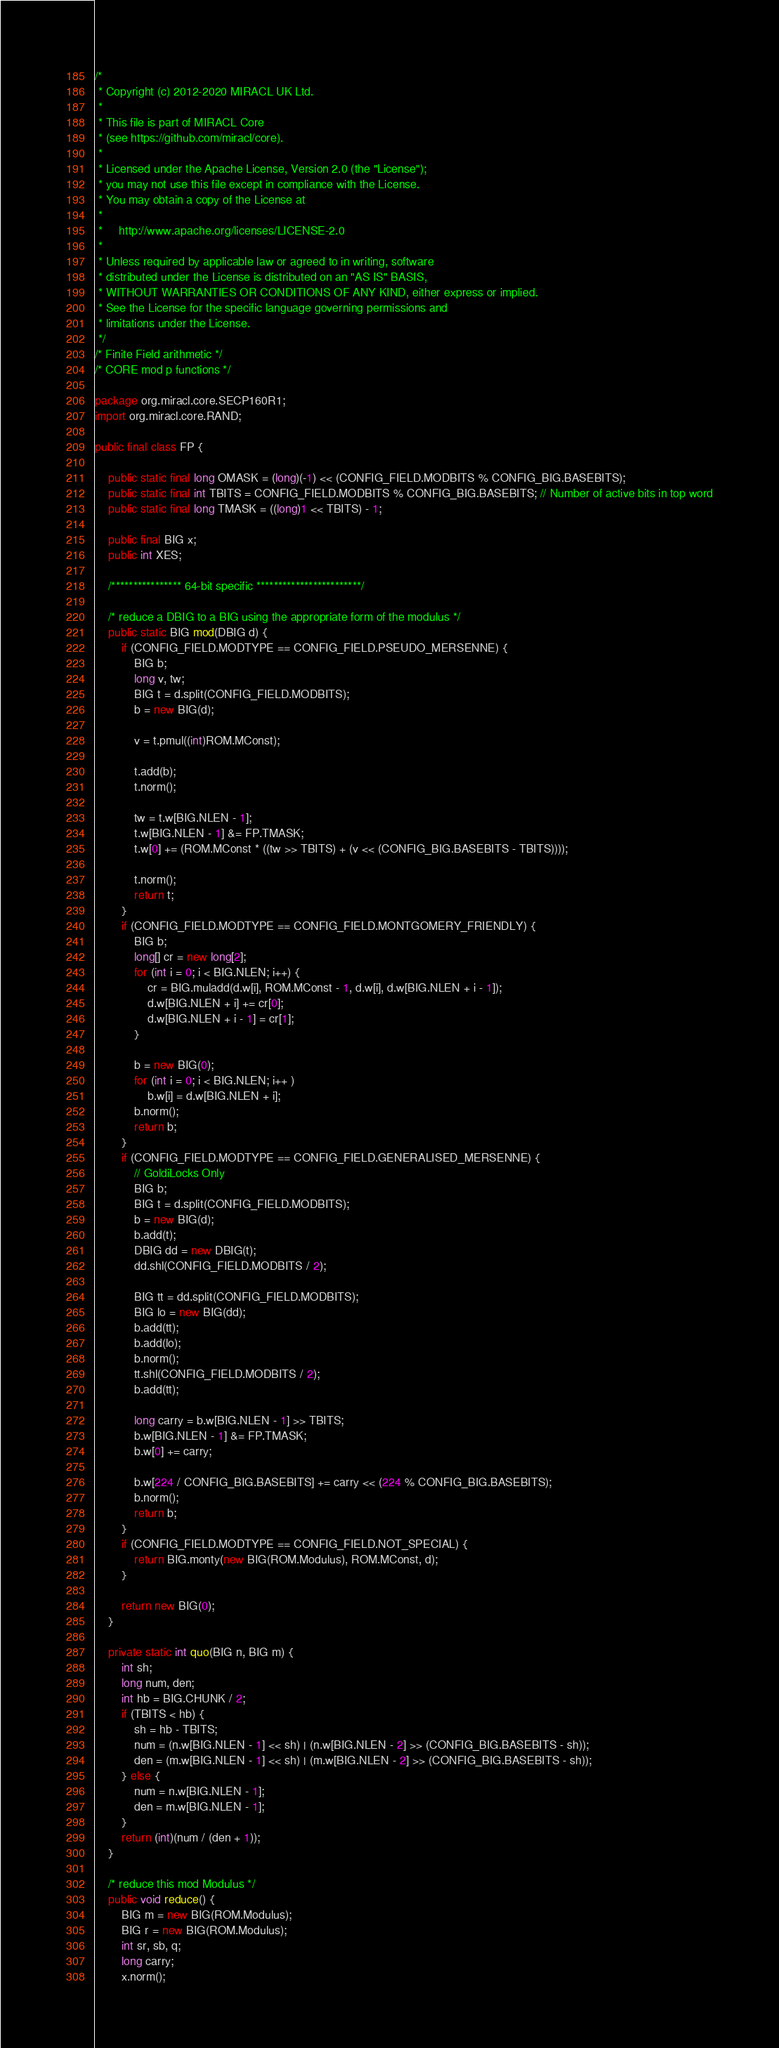<code> <loc_0><loc_0><loc_500><loc_500><_Java_>/*
 * Copyright (c) 2012-2020 MIRACL UK Ltd.
 *
 * This file is part of MIRACL Core
 * (see https://github.com/miracl/core).
 *
 * Licensed under the Apache License, Version 2.0 (the "License");
 * you may not use this file except in compliance with the License.
 * You may obtain a copy of the License at
 *
 *     http://www.apache.org/licenses/LICENSE-2.0
 *
 * Unless required by applicable law or agreed to in writing, software
 * distributed under the License is distributed on an "AS IS" BASIS,
 * WITHOUT WARRANTIES OR CONDITIONS OF ANY KIND, either express or implied.
 * See the License for the specific language governing permissions and
 * limitations under the License.
 */
/* Finite Field arithmetic */
/* CORE mod p functions */

package org.miracl.core.SECP160R1;
import org.miracl.core.RAND;

public final class FP {

    public static final long OMASK = (long)(-1) << (CONFIG_FIELD.MODBITS % CONFIG_BIG.BASEBITS);
    public static final int TBITS = CONFIG_FIELD.MODBITS % CONFIG_BIG.BASEBITS; // Number of active bits in top word
    public static final long TMASK = ((long)1 << TBITS) - 1;

    public final BIG x;
    public int XES;

    /**************** 64-bit specific ************************/

    /* reduce a DBIG to a BIG using the appropriate form of the modulus */
    public static BIG mod(DBIG d) {
        if (CONFIG_FIELD.MODTYPE == CONFIG_FIELD.PSEUDO_MERSENNE) {
            BIG b;
            long v, tw;
            BIG t = d.split(CONFIG_FIELD.MODBITS);
            b = new BIG(d);

            v = t.pmul((int)ROM.MConst);

            t.add(b);
            t.norm();

            tw = t.w[BIG.NLEN - 1];
            t.w[BIG.NLEN - 1] &= FP.TMASK;
            t.w[0] += (ROM.MConst * ((tw >> TBITS) + (v << (CONFIG_BIG.BASEBITS - TBITS))));

            t.norm();
            return t;
        }
        if (CONFIG_FIELD.MODTYPE == CONFIG_FIELD.MONTGOMERY_FRIENDLY) {
            BIG b;
            long[] cr = new long[2];
            for (int i = 0; i < BIG.NLEN; i++) {
                cr = BIG.muladd(d.w[i], ROM.MConst - 1, d.w[i], d.w[BIG.NLEN + i - 1]);
                d.w[BIG.NLEN + i] += cr[0];
                d.w[BIG.NLEN + i - 1] = cr[1];
            }

            b = new BIG(0);
            for (int i = 0; i < BIG.NLEN; i++ )
                b.w[i] = d.w[BIG.NLEN + i];
            b.norm();
            return b;
        }
        if (CONFIG_FIELD.MODTYPE == CONFIG_FIELD.GENERALISED_MERSENNE) {
            // GoldiLocks Only
            BIG b;
            BIG t = d.split(CONFIG_FIELD.MODBITS);
            b = new BIG(d);
            b.add(t);
            DBIG dd = new DBIG(t);
            dd.shl(CONFIG_FIELD.MODBITS / 2);

            BIG tt = dd.split(CONFIG_FIELD.MODBITS);
            BIG lo = new BIG(dd);
            b.add(tt);
            b.add(lo);
            b.norm();
            tt.shl(CONFIG_FIELD.MODBITS / 2);
            b.add(tt);

            long carry = b.w[BIG.NLEN - 1] >> TBITS;
            b.w[BIG.NLEN - 1] &= FP.TMASK;
            b.w[0] += carry;

            b.w[224 / CONFIG_BIG.BASEBITS] += carry << (224 % CONFIG_BIG.BASEBITS);
            b.norm();
            return b;
        }
        if (CONFIG_FIELD.MODTYPE == CONFIG_FIELD.NOT_SPECIAL) {
            return BIG.monty(new BIG(ROM.Modulus), ROM.MConst, d);
        }

        return new BIG(0);
    }

    private static int quo(BIG n, BIG m) {
        int sh;
        long num, den;
        int hb = BIG.CHUNK / 2;
        if (TBITS < hb) {
            sh = hb - TBITS;
            num = (n.w[BIG.NLEN - 1] << sh) | (n.w[BIG.NLEN - 2] >> (CONFIG_BIG.BASEBITS - sh));
            den = (m.w[BIG.NLEN - 1] << sh) | (m.w[BIG.NLEN - 2] >> (CONFIG_BIG.BASEBITS - sh));
        } else {
            num = n.w[BIG.NLEN - 1];
            den = m.w[BIG.NLEN - 1];
        }
        return (int)(num / (den + 1));
    }

    /* reduce this mod Modulus */
    public void reduce() {
        BIG m = new BIG(ROM.Modulus);
        BIG r = new BIG(ROM.Modulus);
        int sr, sb, q;
        long carry;
        x.norm();
</code> 